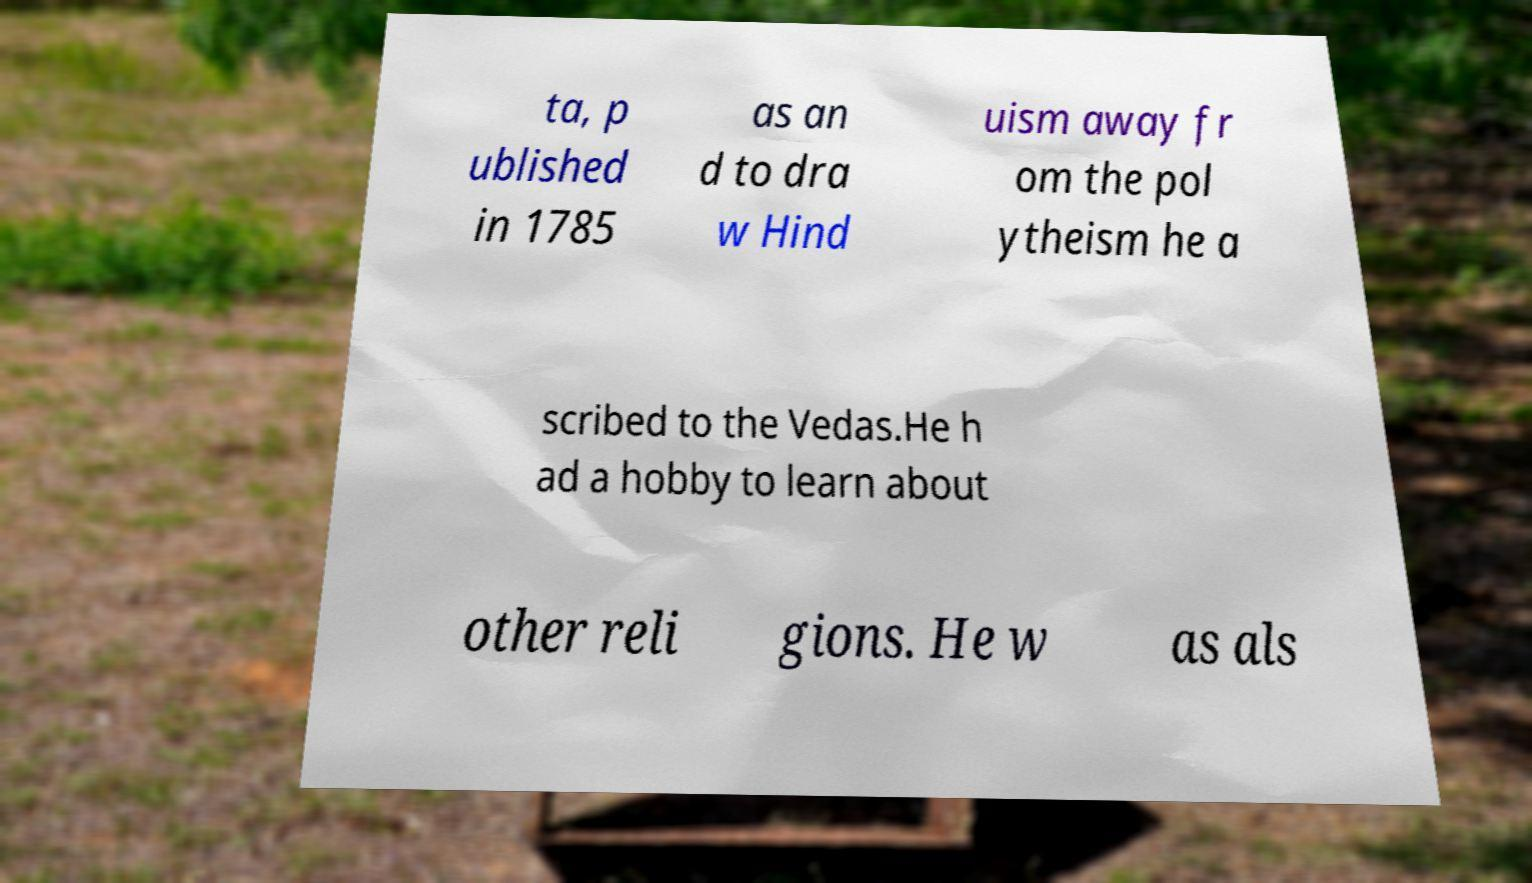I need the written content from this picture converted into text. Can you do that? ta, p ublished in 1785 as an d to dra w Hind uism away fr om the pol ytheism he a scribed to the Vedas.He h ad a hobby to learn about other reli gions. He w as als 